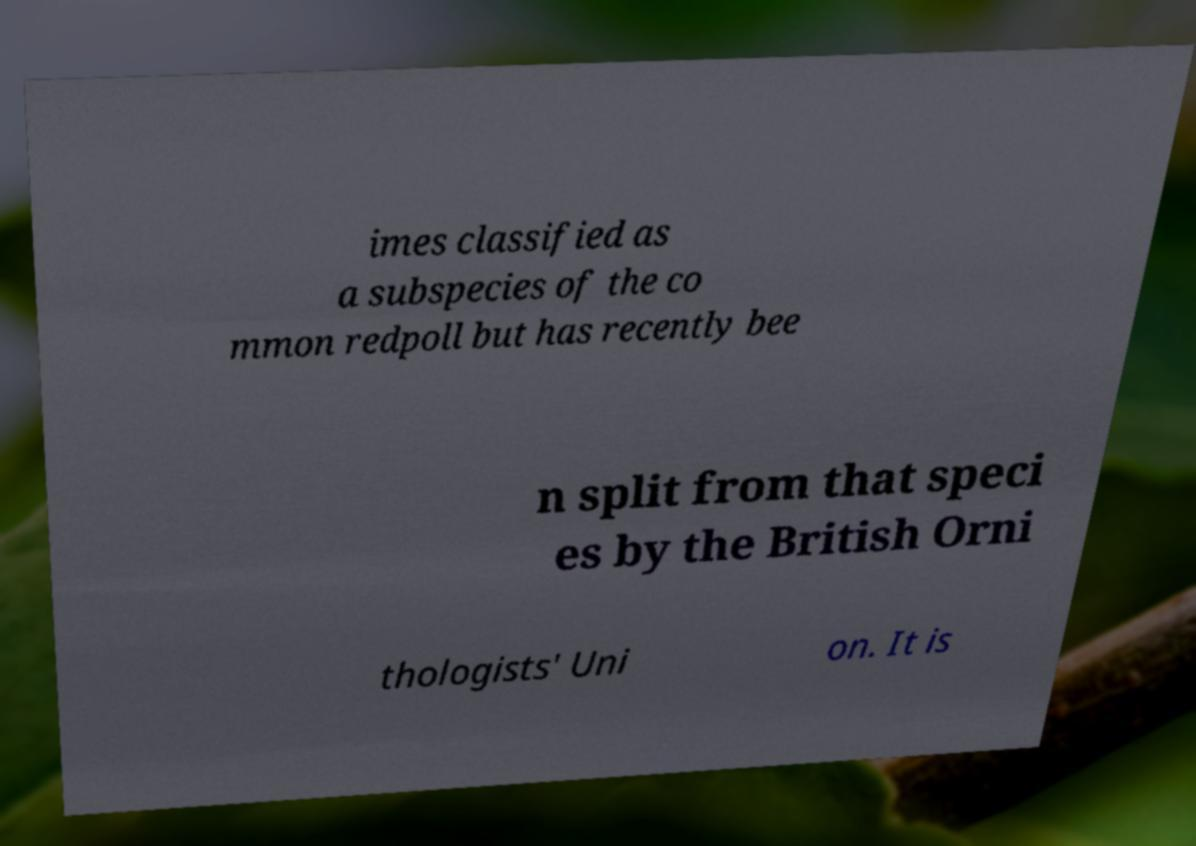Could you extract and type out the text from this image? imes classified as a subspecies of the co mmon redpoll but has recently bee n split from that speci es by the British Orni thologists' Uni on. It is 